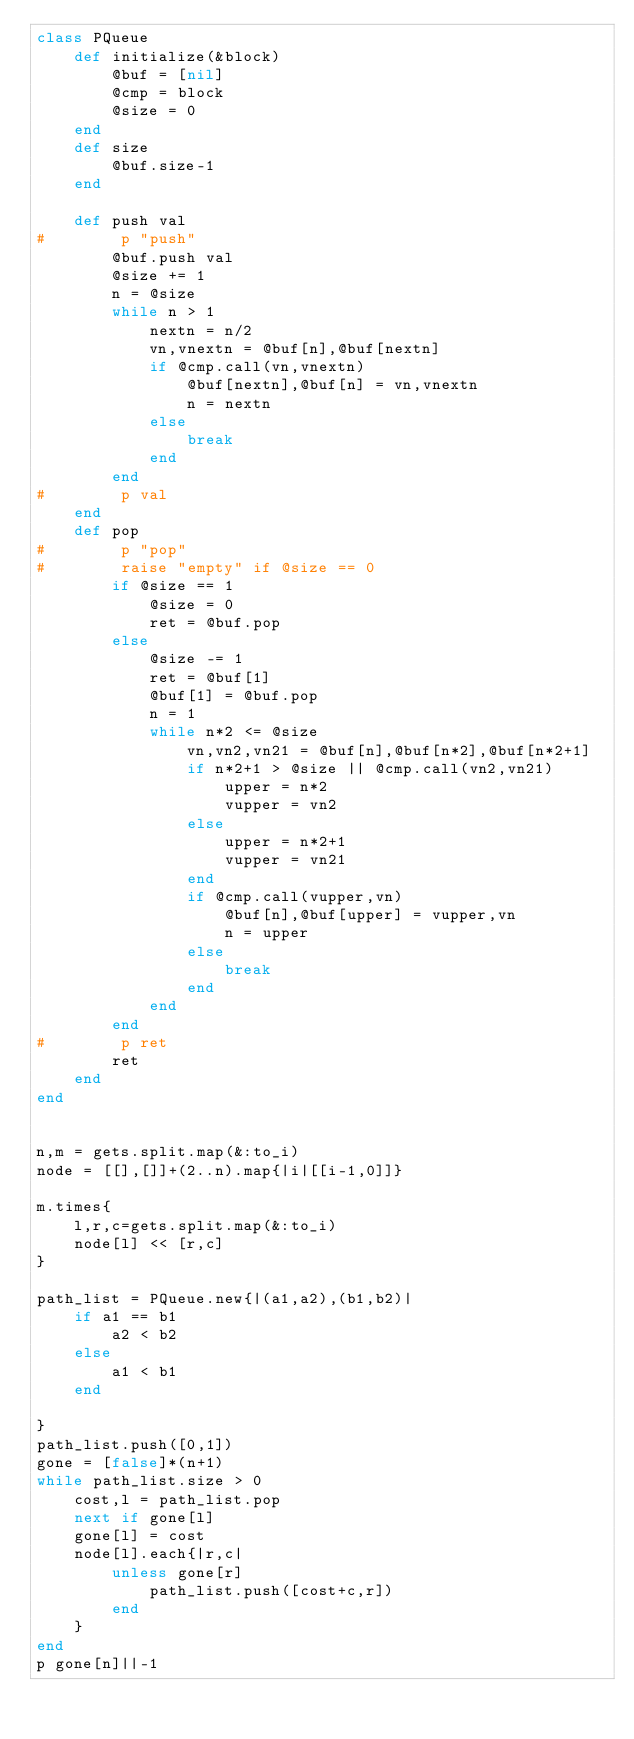<code> <loc_0><loc_0><loc_500><loc_500><_Ruby_>class PQueue
    def initialize(&block)
        @buf = [nil]
        @cmp = block
        @size = 0
    end
    def size
        @buf.size-1
    end

    def push val
#        p "push"
        @buf.push val
        @size += 1
        n = @size
        while n > 1
            nextn = n/2
            vn,vnextn = @buf[n],@buf[nextn]
            if @cmp.call(vn,vnextn)
                @buf[nextn],@buf[n] = vn,vnextn
                n = nextn
            else
                break
            end
        end
#        p val
    end
    def pop
#        p "pop"
#        raise "empty" if @size == 0
        if @size == 1
            @size = 0
            ret = @buf.pop
        else
            @size -= 1
            ret = @buf[1]
            @buf[1] = @buf.pop
            n = 1
            while n*2 <= @size
                vn,vn2,vn21 = @buf[n],@buf[n*2],@buf[n*2+1]
                if n*2+1 > @size || @cmp.call(vn2,vn21)
                    upper = n*2
                    vupper = vn2
                else
                    upper = n*2+1
                    vupper = vn21
                end
                if @cmp.call(vupper,vn)
                    @buf[n],@buf[upper] = vupper,vn
                    n = upper
                else
                    break
                end
            end
        end
#        p ret
        ret
    end
end


n,m = gets.split.map(&:to_i)
node = [[],[]]+(2..n).map{|i|[[i-1,0]]}

m.times{
    l,r,c=gets.split.map(&:to_i)
    node[l] << [r,c]
}

path_list = PQueue.new{|(a1,a2),(b1,b2)|
    if a1 == b1
        a2 < b2
    else
        a1 < b1
    end
        
}
path_list.push([0,1])
gone = [false]*(n+1)
while path_list.size > 0
    cost,l = path_list.pop
    next if gone[l]
    gone[l] = cost
    node[l].each{|r,c|
        unless gone[r]
            path_list.push([cost+c,r])
        end
    }
end
p gone[n]||-1
</code> 